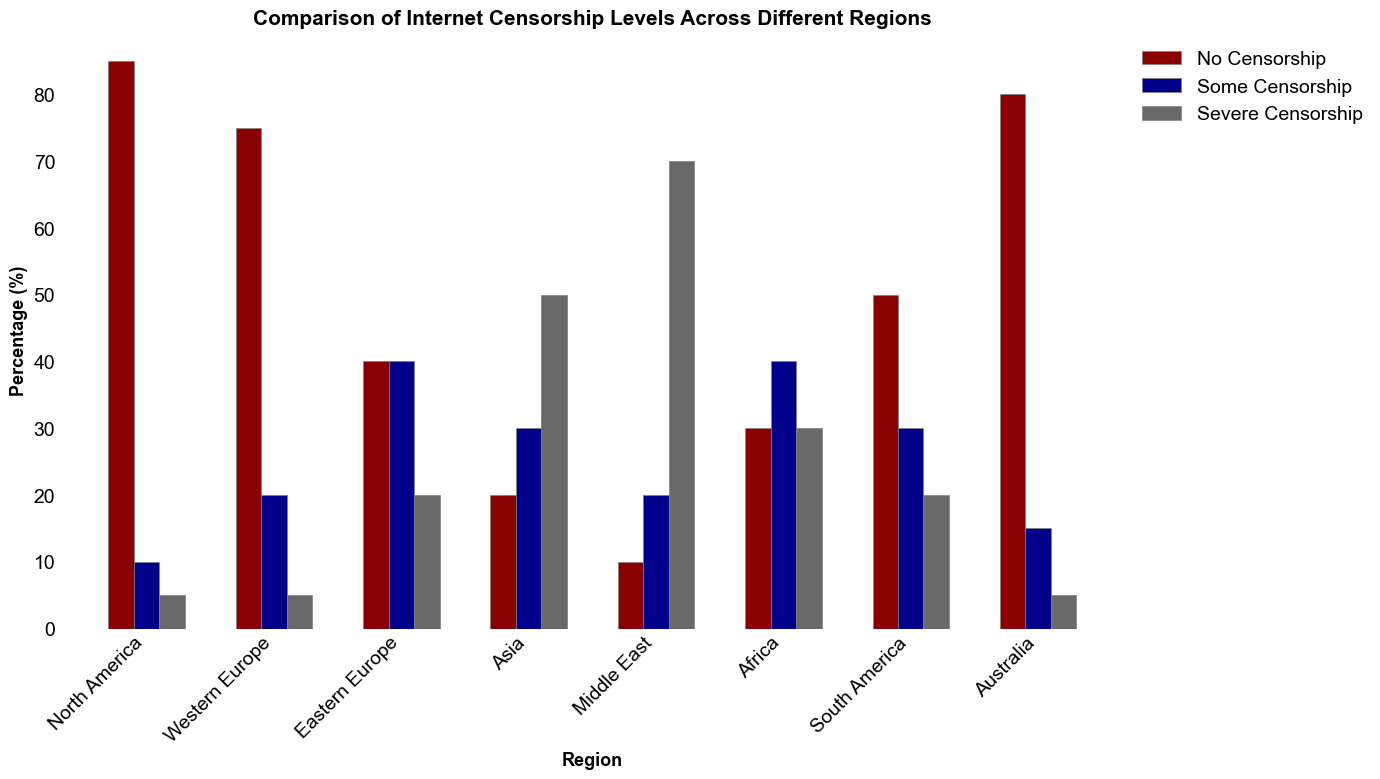Which region has the highest percentage of "Severe Censorship"? By observing the height of the bars in the "Severe Censorship" category, we can see that the Middle East has the tallest bar, indicating the highest percentage of severe censorship at 70%.
Answer: Middle East Which two regions have an equal percentage of "Severe Censorship"? By comparing the height of the "Severe Censorship" bars, we see that North America and Western Europe both have bars that reach up to 5%, indicating they have equal percentages of severe censorship.
Answer: North America and Western Europe How does the level of "No Censorship" in South America compare to that in Africa? By looking at the heights of the bars for "No Censorship", South America's bar reaches 50% while Africa's reaches 30%. Therefore, South America has a higher level of no censorship compared to Africa.
Answer: South America has more "No Censorship" than Africa Which region has the lowest percentage of "No Censorship"? By identifying the shortest bar in the "No Censorship" category, we find that the Middle East has the lowest percentage at 10%.
Answer: Middle East What is the average percentage of "Some Censorship" across all regions? To find the average, first sum the percentages of "Some Censorship" across all regions: (10 + 20 + 40 + 30 + 20 + 40 + 30 + 15) = 205%. Then, divide by the number of regions (8), resulting in an average of 205/8 = 25.625%.
Answer: 25.625% Which region exhibits the largest disparity between "No Censorship" and "Severe Censorship"? The largest disparity can be determined by comparing the difference between "No Censorship" and "Severe Censorship" within each region. The Middle East has "No Censorship" at 10% and "Severe Censorship" at 70%, resulting in a difference of 60%, which is the largest disparity.
Answer: Middle East Compare the levels of "Some Censorship" in Eastern Europe and Africa. Which is higher? By observing the heights of the "Some Censorship" bars, we see that both Eastern Europe and Africa have bars that reach 40%. Thus, they have equal levels of some censorship.
Answer: Equal Which region has a more balanced distribution across the three censorship categories? A more balanced distribution would have similar heights for all three bars. In Eastern Europe, the bars for "No Censorship", "Some Censorship", and "Severe Censorship" are 40%, 40%, and 20% respectively, making it the most balanced region.
Answer: Eastern Europe What is the combined percentage of "No Censorship" and "Some Censorship" in Australia? To find the combined percentage, add the values for "No Censorship" and "Some Censorship" in Australia: 80% + 15% = 95%.
Answer: 95% In which regions does "Severe Censorship" constitute at least 50% of the internet censorship levels? By identifying bars in the "Severe Censorship" category that are at least 50% tall, we find that both Asia and the Middle East have percentages of 50% and 70%, respectively, meeting the criteria.
Answer: Asia and Middle East 